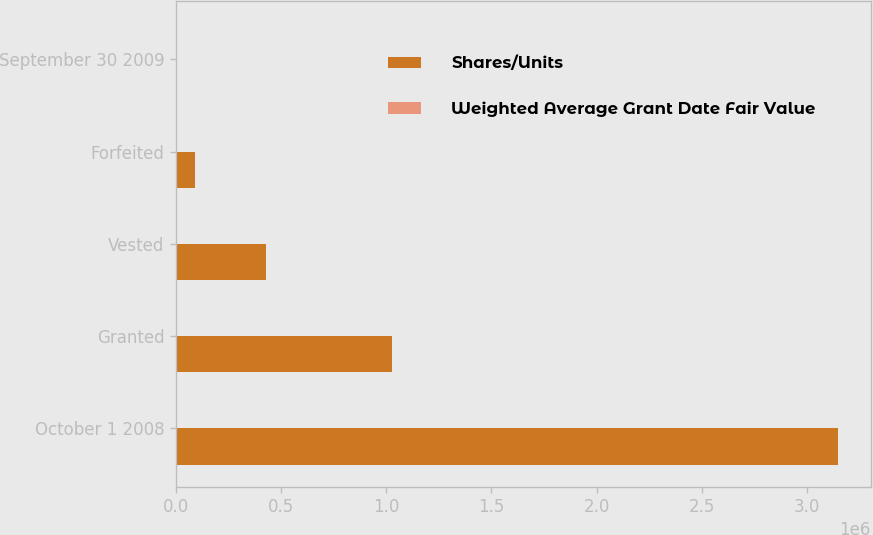Convert chart to OTSL. <chart><loc_0><loc_0><loc_500><loc_500><stacked_bar_chart><ecel><fcel>October 1 2008<fcel>Granted<fcel>Vested<fcel>Forfeited<fcel>September 30 2009<nl><fcel>Shares/Units<fcel>3.14835e+06<fcel>1.027e+06<fcel>426174<fcel>89064<fcel>27.23<nl><fcel>Weighted Average Grant Date Fair Value<fcel>27.23<fcel>17.63<fcel>21.86<fcel>25.25<fcel>25.18<nl></chart> 